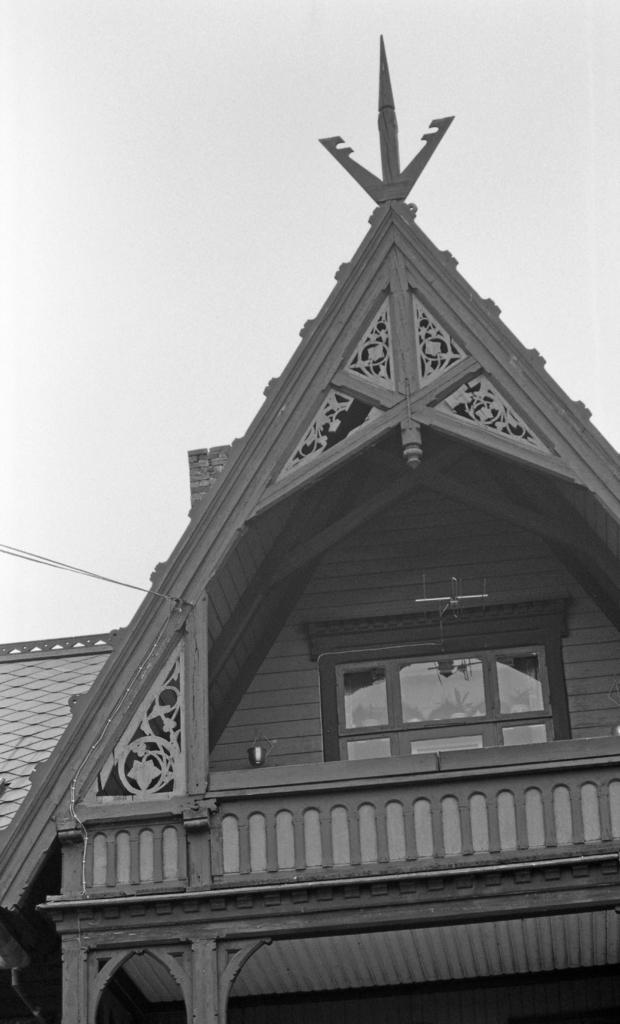Could you give a brief overview of what you see in this image? In this image there is a house. Only the top part of the house is captured in the image. There are glass windows to the walls of the house. To the left there is a roof. At the top there is the sky. 